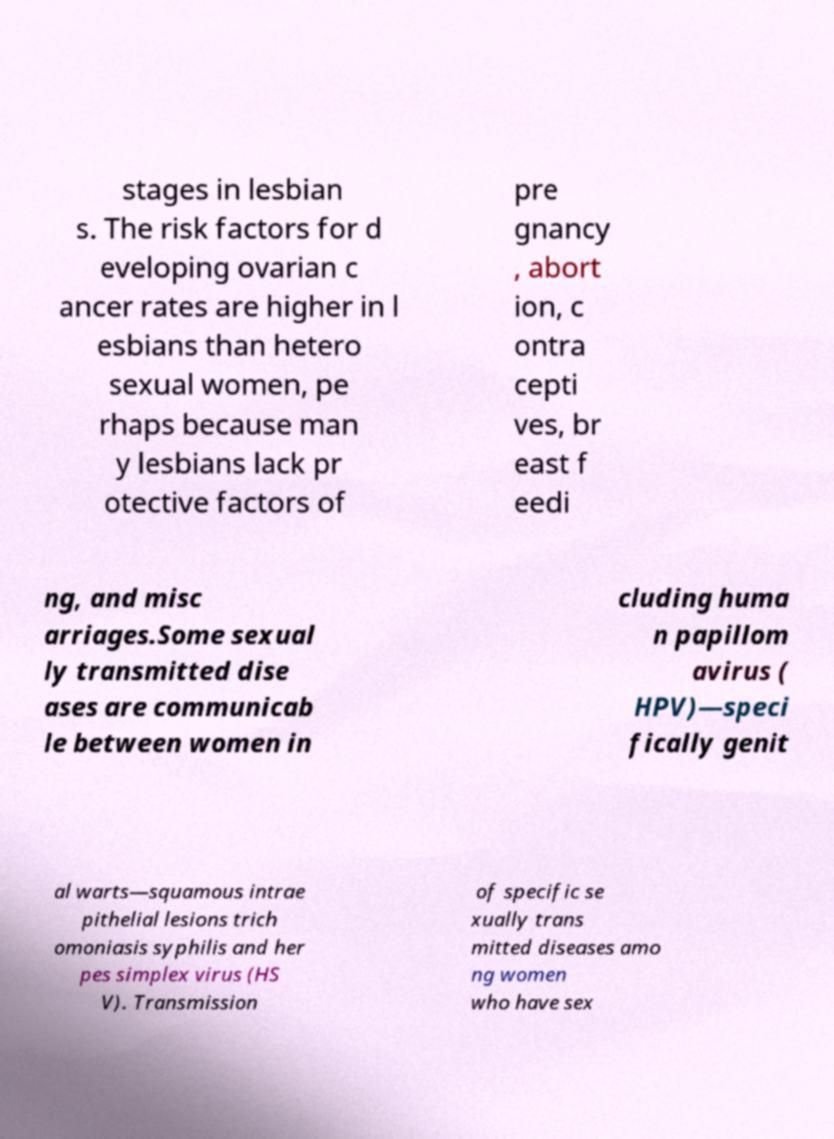Can you read and provide the text displayed in the image?This photo seems to have some interesting text. Can you extract and type it out for me? stages in lesbian s. The risk factors for d eveloping ovarian c ancer rates are higher in l esbians than hetero sexual women, pe rhaps because man y lesbians lack pr otective factors of pre gnancy , abort ion, c ontra cepti ves, br east f eedi ng, and misc arriages.Some sexual ly transmitted dise ases are communicab le between women in cluding huma n papillom avirus ( HPV)—speci fically genit al warts—squamous intrae pithelial lesions trich omoniasis syphilis and her pes simplex virus (HS V). Transmission of specific se xually trans mitted diseases amo ng women who have sex 